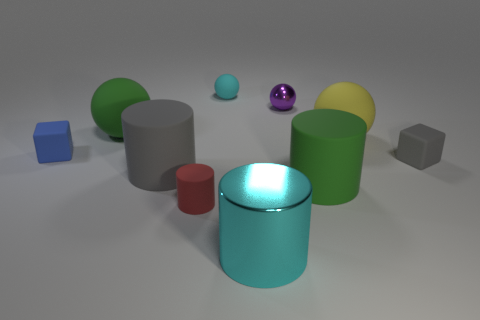There is a purple thing behind the small red object; what material is it?
Ensure brevity in your answer.  Metal. The yellow ball is what size?
Your answer should be compact. Large. There is a matte cylinder to the right of the tiny shiny object; is its size the same as the metallic thing that is behind the green ball?
Your answer should be very brief. No. What size is the other thing that is the same shape as the small blue rubber object?
Your answer should be very brief. Small. Is the size of the yellow matte sphere the same as the rubber cylinder on the right side of the small cyan rubber ball?
Make the answer very short. Yes. Are there any large matte cylinders that are on the right side of the big green thing to the right of the cyan matte thing?
Offer a terse response. No. The large green thing behind the large gray cylinder has what shape?
Your response must be concise. Sphere. There is a sphere that is the same color as the big shiny thing; what is it made of?
Make the answer very short. Rubber. There is a tiny thing that is right of the cylinder that is right of the large cyan metallic cylinder; what color is it?
Your answer should be very brief. Gray. Does the red rubber thing have the same size as the gray matte cube?
Make the answer very short. Yes. 